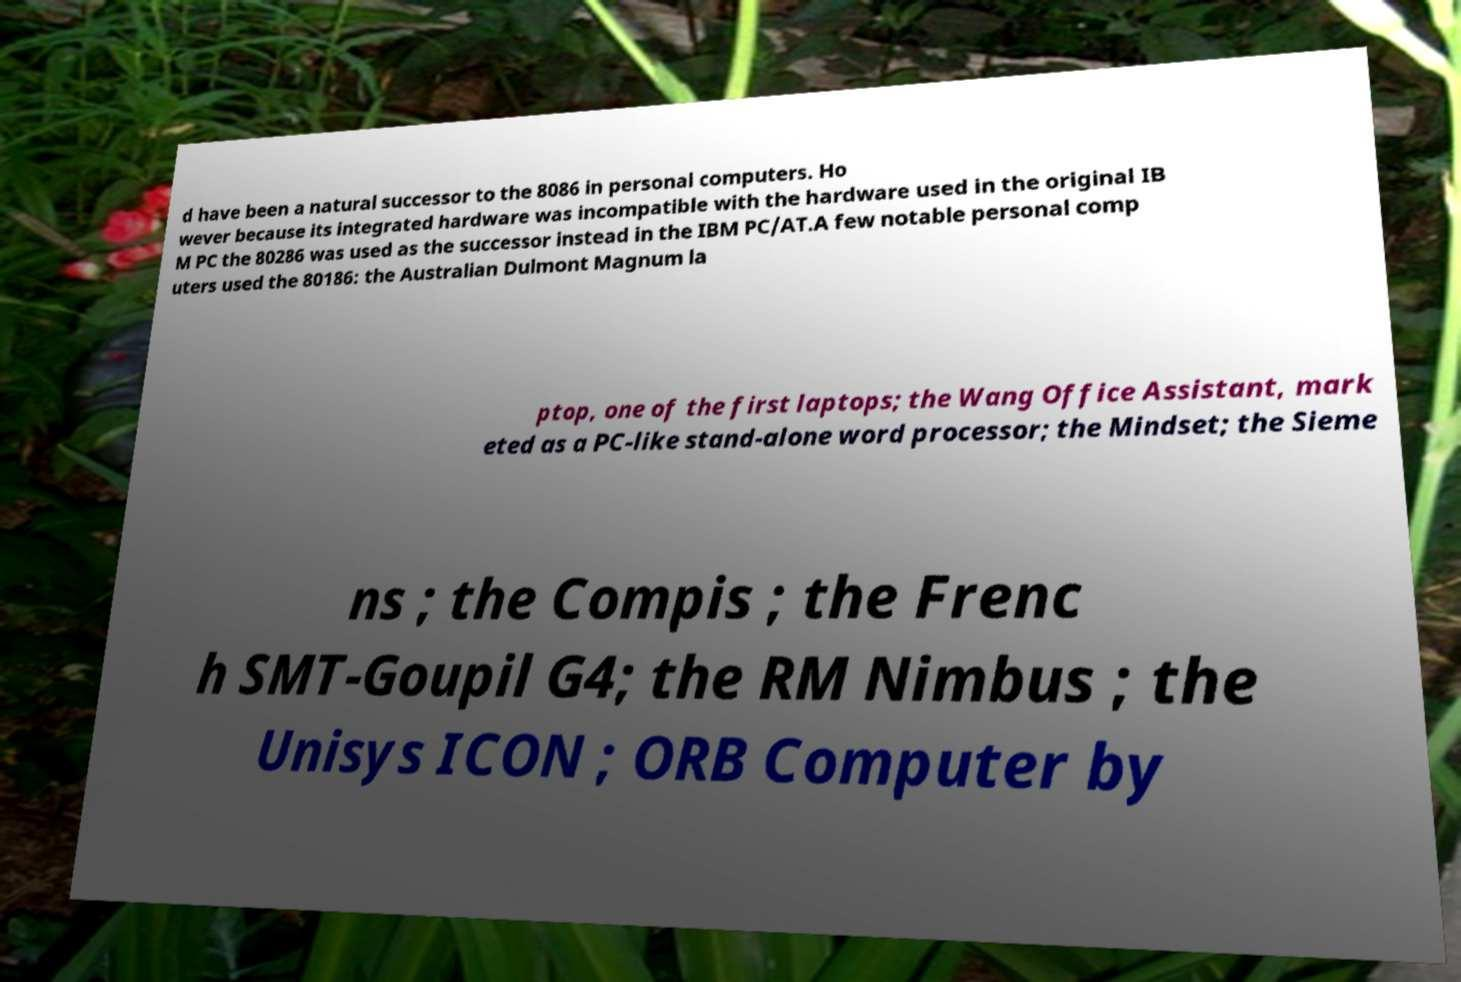Could you extract and type out the text from this image? d have been a natural successor to the 8086 in personal computers. Ho wever because its integrated hardware was incompatible with the hardware used in the original IB M PC the 80286 was used as the successor instead in the IBM PC/AT.A few notable personal comp uters used the 80186: the Australian Dulmont Magnum la ptop, one of the first laptops; the Wang Office Assistant, mark eted as a PC-like stand-alone word processor; the Mindset; the Sieme ns ; the Compis ; the Frenc h SMT-Goupil G4; the RM Nimbus ; the Unisys ICON ; ORB Computer by 